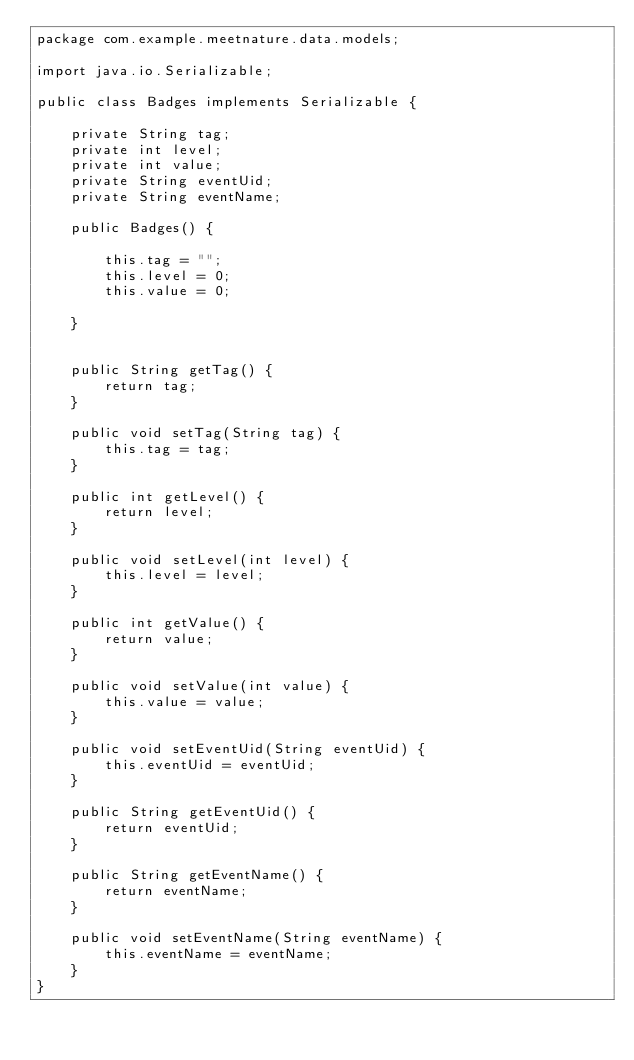Convert code to text. <code><loc_0><loc_0><loc_500><loc_500><_Java_>package com.example.meetnature.data.models;

import java.io.Serializable;

public class Badges implements Serializable {

    private String tag;
    private int level;
    private int value;
    private String eventUid;
    private String eventName;

    public Badges() {

        this.tag = "";
        this.level = 0;
        this.value = 0;

    }


    public String getTag() {
        return tag;
    }

    public void setTag(String tag) {
        this.tag = tag;
    }

    public int getLevel() {
        return level;
    }

    public void setLevel(int level) {
        this.level = level;
    }

    public int getValue() {
        return value;
    }

    public void setValue(int value) {
        this.value = value;
    }

    public void setEventUid(String eventUid) {
        this.eventUid = eventUid;
    }

    public String getEventUid() {
        return eventUid;
    }

    public String getEventName() {
        return eventName;
    }

    public void setEventName(String eventName) {
        this.eventName = eventName;
    }
}
</code> 